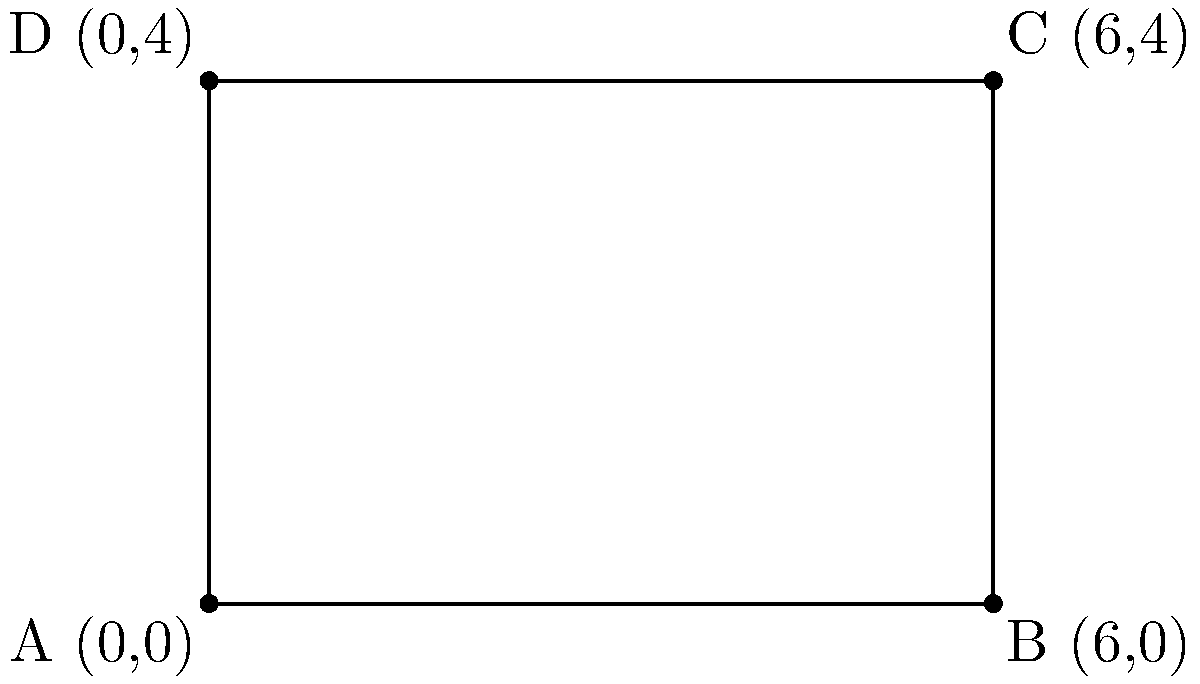In your job as a janitor, you need to calculate the area of a rectangular room to order the right amount of cleaning supplies. The room's corners are represented by the following coordinates: A(0,0), B(6,0), C(6,4), and D(0,4). What is the area of this rectangular room in square units? To find the area of a rectangle using coordinates, we can follow these steps:

1. Calculate the length of the rectangle:
   The length is the distance between points A and B (or D and C).
   Length = $|x_B - x_A| = |6 - 0| = 6$ units

2. Calculate the width of the rectangle:
   The width is the distance between points A and D (or B and C).
   Width = $|y_D - y_A| = |4 - 0| = 4$ units

3. Calculate the area using the formula:
   Area = length × width
   Area = $6 \times 4 = 24$ square units

Therefore, the area of the rectangular room is 24 square units.
Answer: 24 square units 